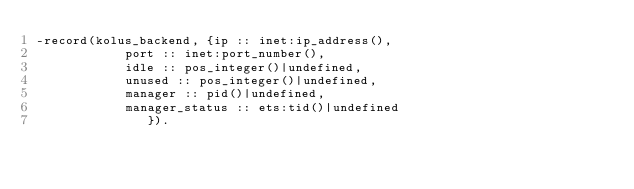<code> <loc_0><loc_0><loc_500><loc_500><_Erlang_>-record(kolus_backend, {ip :: inet:ip_address(),
			port :: inet:port_number(),
			idle :: pos_integer()|undefined,
			unused :: pos_integer()|undefined,
			manager :: pid()|undefined,
			manager_status :: ets:tid()|undefined
		       }).
</code> 